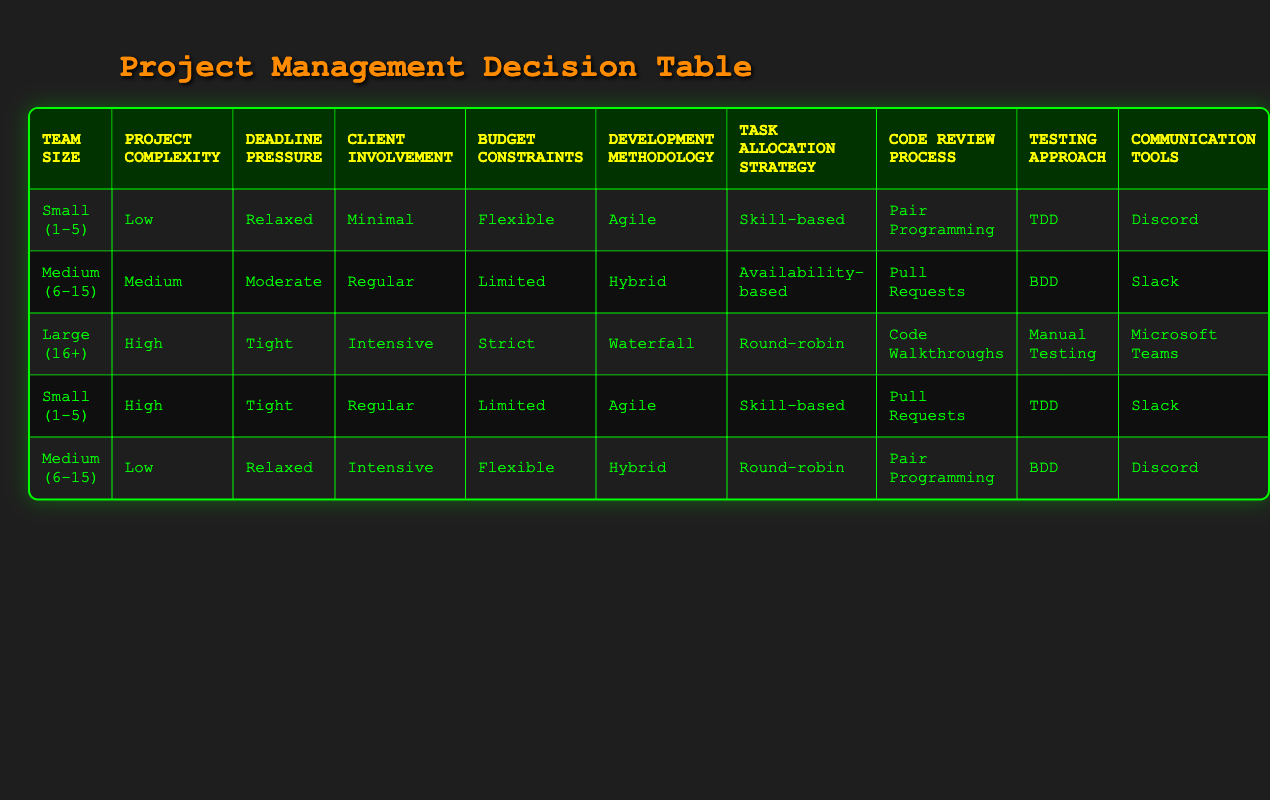What development methodology is suggested for a small team working on a low-complexity project with relaxed deadlines? The table shows that for a small team (1-5 members) working on a low-complexity project with relaxed deadlines, the recommended development methodology is Agile.
Answer: Agile How many different task allocation strategies are listed in the table? The table lists three task allocation strategies: Skill-based, Availability-based, and Round-robin. Therefore, there are three different strategies.
Answer: 3 Is Agile the recommended methodology for projects with high complexity? According to the table, Agile is suggested for a small team working on high complexity projects with tight deadlines, indicating that not all high complexity projects will utilize Agile. Thus, the statement is false.
Answer: No Which communication tool is suggested for a medium-sized team under moderate deadline pressure with limited budget constraints? Referring to the table, for a medium team (6-15 members) under moderate deadline pressure with limited budget constraints, Slack is the suggested communication tool.
Answer: Slack Compare the code review processes suggested for small teams working on low complexity versus high complexity projects. The table indicates that a small team on a low complexity project uses Pair Programming for code reviews, while for a high complexity project, Pull Requests are suggested. Thus, the two methods differ based on project complexity.
Answer: Different methods What is the most common testing approach mentioned for medium-sized teams? The table provides testing approaches for two scenarios involving medium teams: BDD for medium complexity and relaxed deadlines, and BDD again under relaxed deadlines but with intensive client involvement. Since BDD appears twice, it can be inferred as the most common approach for medium-sized teams in the table.
Answer: BDD For which combination of conditions is the Communication Tool "Microsoft Teams" recommended? Checking the table, "Microsoft Teams" is recommended for the large team (16+), high complexity, tight deadline, intensive client involvement, and strict budget constraints.
Answer: Large team conditions What is the average number of project complexity levels listed in the table? The table presents three project complexity levels: Low, Medium, and High. To find the average, we note that there are three distinct levels, so the average remains 3-levels total.
Answer: 3 How many entries in the table suggest using “Pull Requests” for the code review process? From examining the table, "Pull Requests" is listed in two entries: Small team with high complexity and medium complexity. Hence, it appears twice in the table.
Answer: 2 